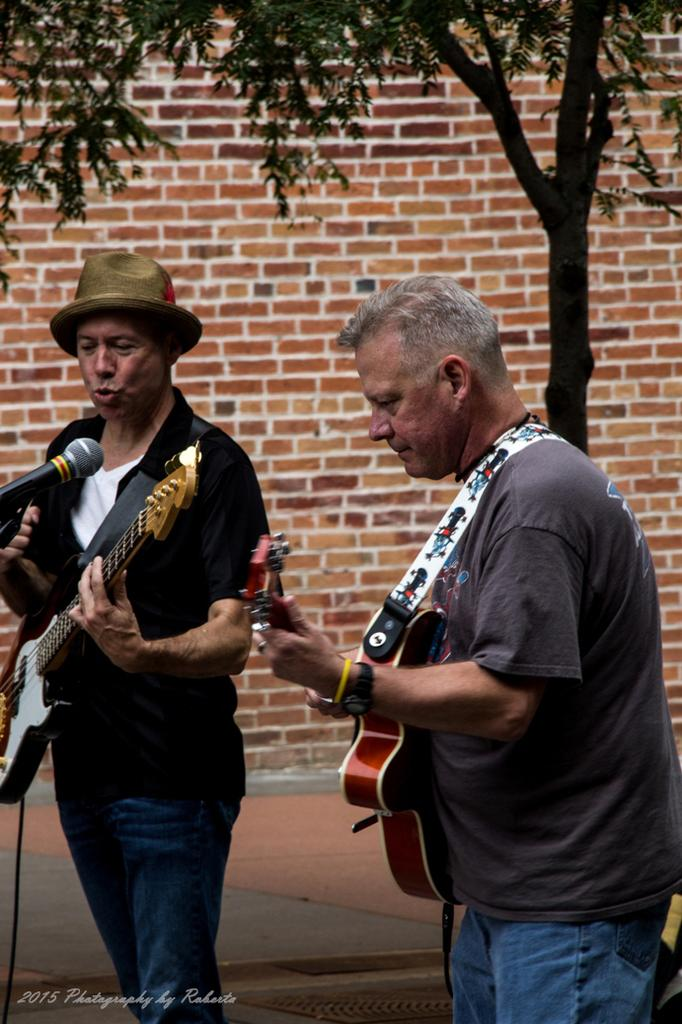How many people are in the image? There are two persons in the image. What are the persons doing in the image? The persons are standing and playing guitar. Can you describe the clothing of one of the persons? One person is wearing a cap. What is the person wearing a cap doing in the image? The person wearing a cap is singing on a microphone. What can be seen in the background of the image? There is a brick wall and a tree visible in the background of the image. How much money is being exchanged between the two persons in the image? There is no indication of money being exchanged between the two persons in the image. What type of behavior is being displayed by the tree in the background of the image? The tree in the background of the image is not displaying any behavior, as it is an inanimate object. 